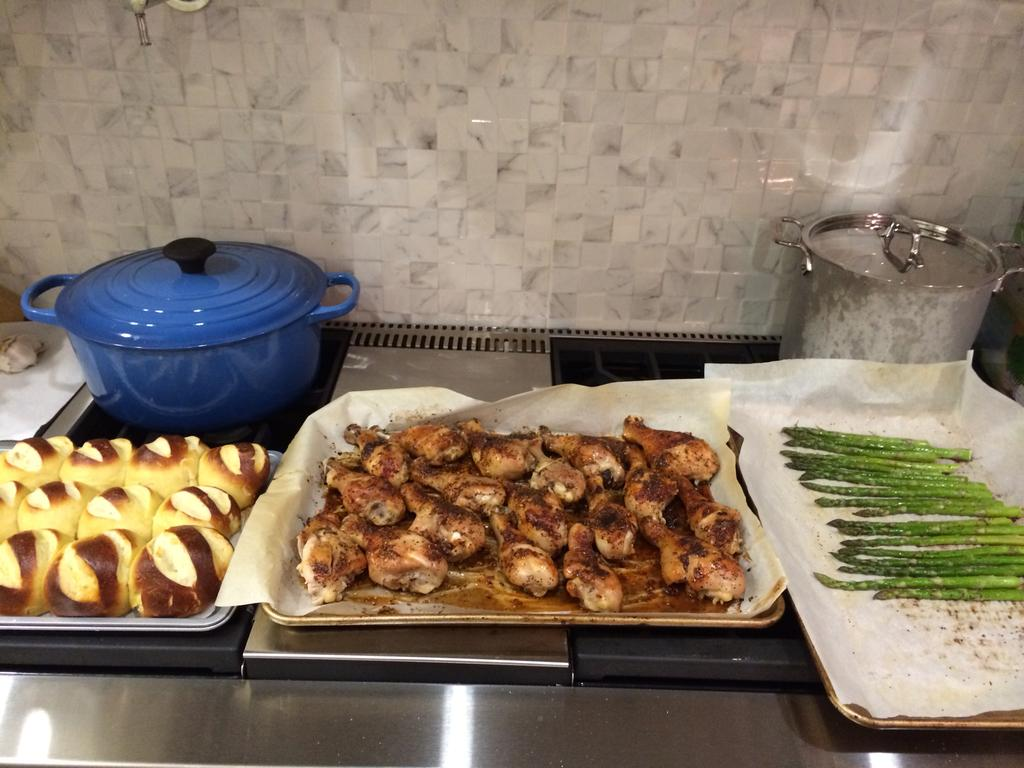What is placed on the desk in the image? There is food placed on the desk in the image. Can you describe the colors of the food? The food has brown and green colors. What type of dish is on the left side of the desk? There is a blue color dish on the left side of the desk. What can be seen in the background of the image? There is a wall visible in the background of the image. Is there a suit hanging on the wall in the image? There is no suit visible in the image; only food, a dish, and a wall are present. Can you see a swing in the image? There is no swing present in the image. 